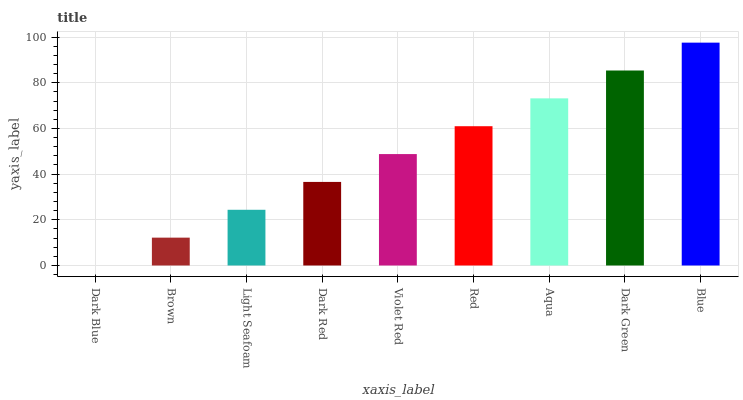Is Dark Blue the minimum?
Answer yes or no. Yes. Is Blue the maximum?
Answer yes or no. Yes. Is Brown the minimum?
Answer yes or no. No. Is Brown the maximum?
Answer yes or no. No. Is Brown greater than Dark Blue?
Answer yes or no. Yes. Is Dark Blue less than Brown?
Answer yes or no. Yes. Is Dark Blue greater than Brown?
Answer yes or no. No. Is Brown less than Dark Blue?
Answer yes or no. No. Is Violet Red the high median?
Answer yes or no. Yes. Is Violet Red the low median?
Answer yes or no. Yes. Is Brown the high median?
Answer yes or no. No. Is Aqua the low median?
Answer yes or no. No. 